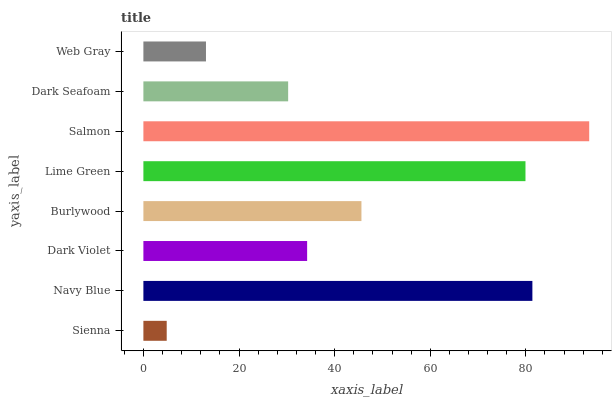Is Sienna the minimum?
Answer yes or no. Yes. Is Salmon the maximum?
Answer yes or no. Yes. Is Navy Blue the minimum?
Answer yes or no. No. Is Navy Blue the maximum?
Answer yes or no. No. Is Navy Blue greater than Sienna?
Answer yes or no. Yes. Is Sienna less than Navy Blue?
Answer yes or no. Yes. Is Sienna greater than Navy Blue?
Answer yes or no. No. Is Navy Blue less than Sienna?
Answer yes or no. No. Is Burlywood the high median?
Answer yes or no. Yes. Is Dark Violet the low median?
Answer yes or no. Yes. Is Web Gray the high median?
Answer yes or no. No. Is Web Gray the low median?
Answer yes or no. No. 